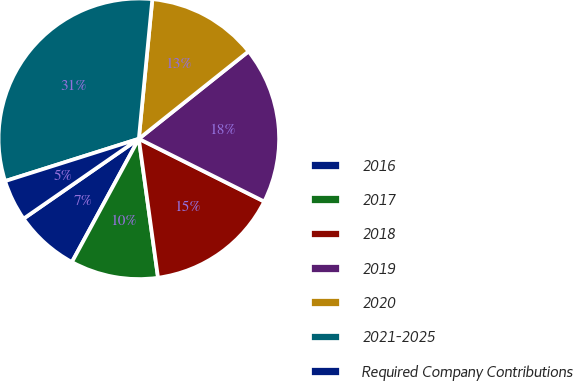Convert chart. <chart><loc_0><loc_0><loc_500><loc_500><pie_chart><fcel>2016<fcel>2017<fcel>2018<fcel>2019<fcel>2020<fcel>2021-2025<fcel>Required Company Contributions<nl><fcel>7.44%<fcel>10.1%<fcel>15.43%<fcel>18.09%<fcel>12.76%<fcel>31.41%<fcel>4.77%<nl></chart> 